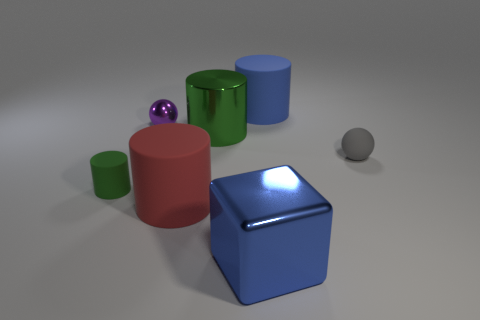Subtract all green cylinders. How many were subtracted if there are1green cylinders left? 1 Subtract all cyan spheres. How many green cylinders are left? 2 Add 2 large red cylinders. How many objects exist? 9 Subtract all big metal cylinders. How many cylinders are left? 3 Subtract all red cylinders. How many cylinders are left? 3 Subtract all yellow cylinders. Subtract all gray blocks. How many cylinders are left? 4 Add 4 purple shiny things. How many purple shiny things exist? 5 Subtract 0 gray cubes. How many objects are left? 7 Subtract all cylinders. How many objects are left? 3 Subtract all cyan metal things. Subtract all green objects. How many objects are left? 5 